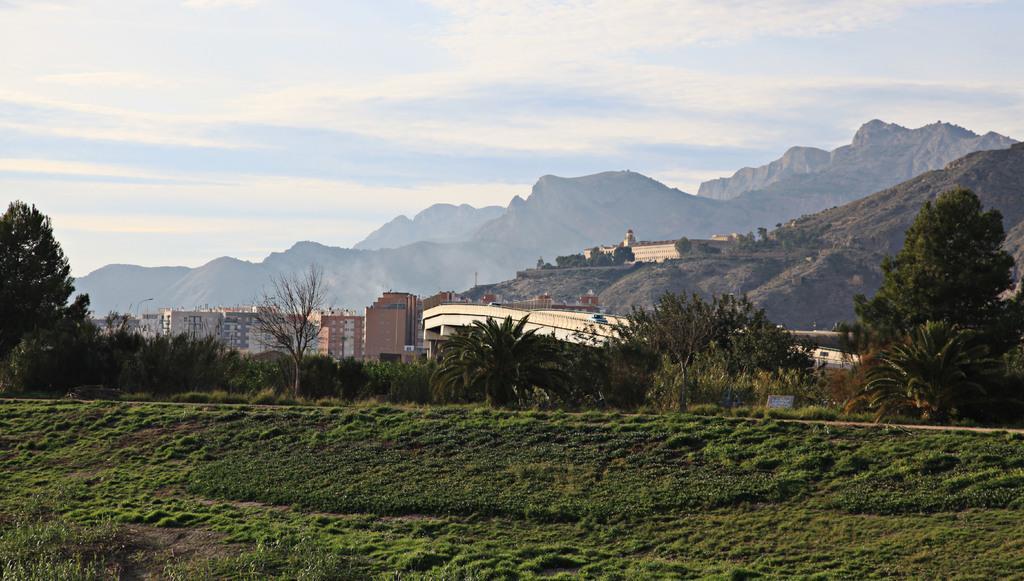Please provide a concise description of this image. In this image we can see there is a grass, trees, plants, buildings, board and a mountain. And at the top there is a sky. 